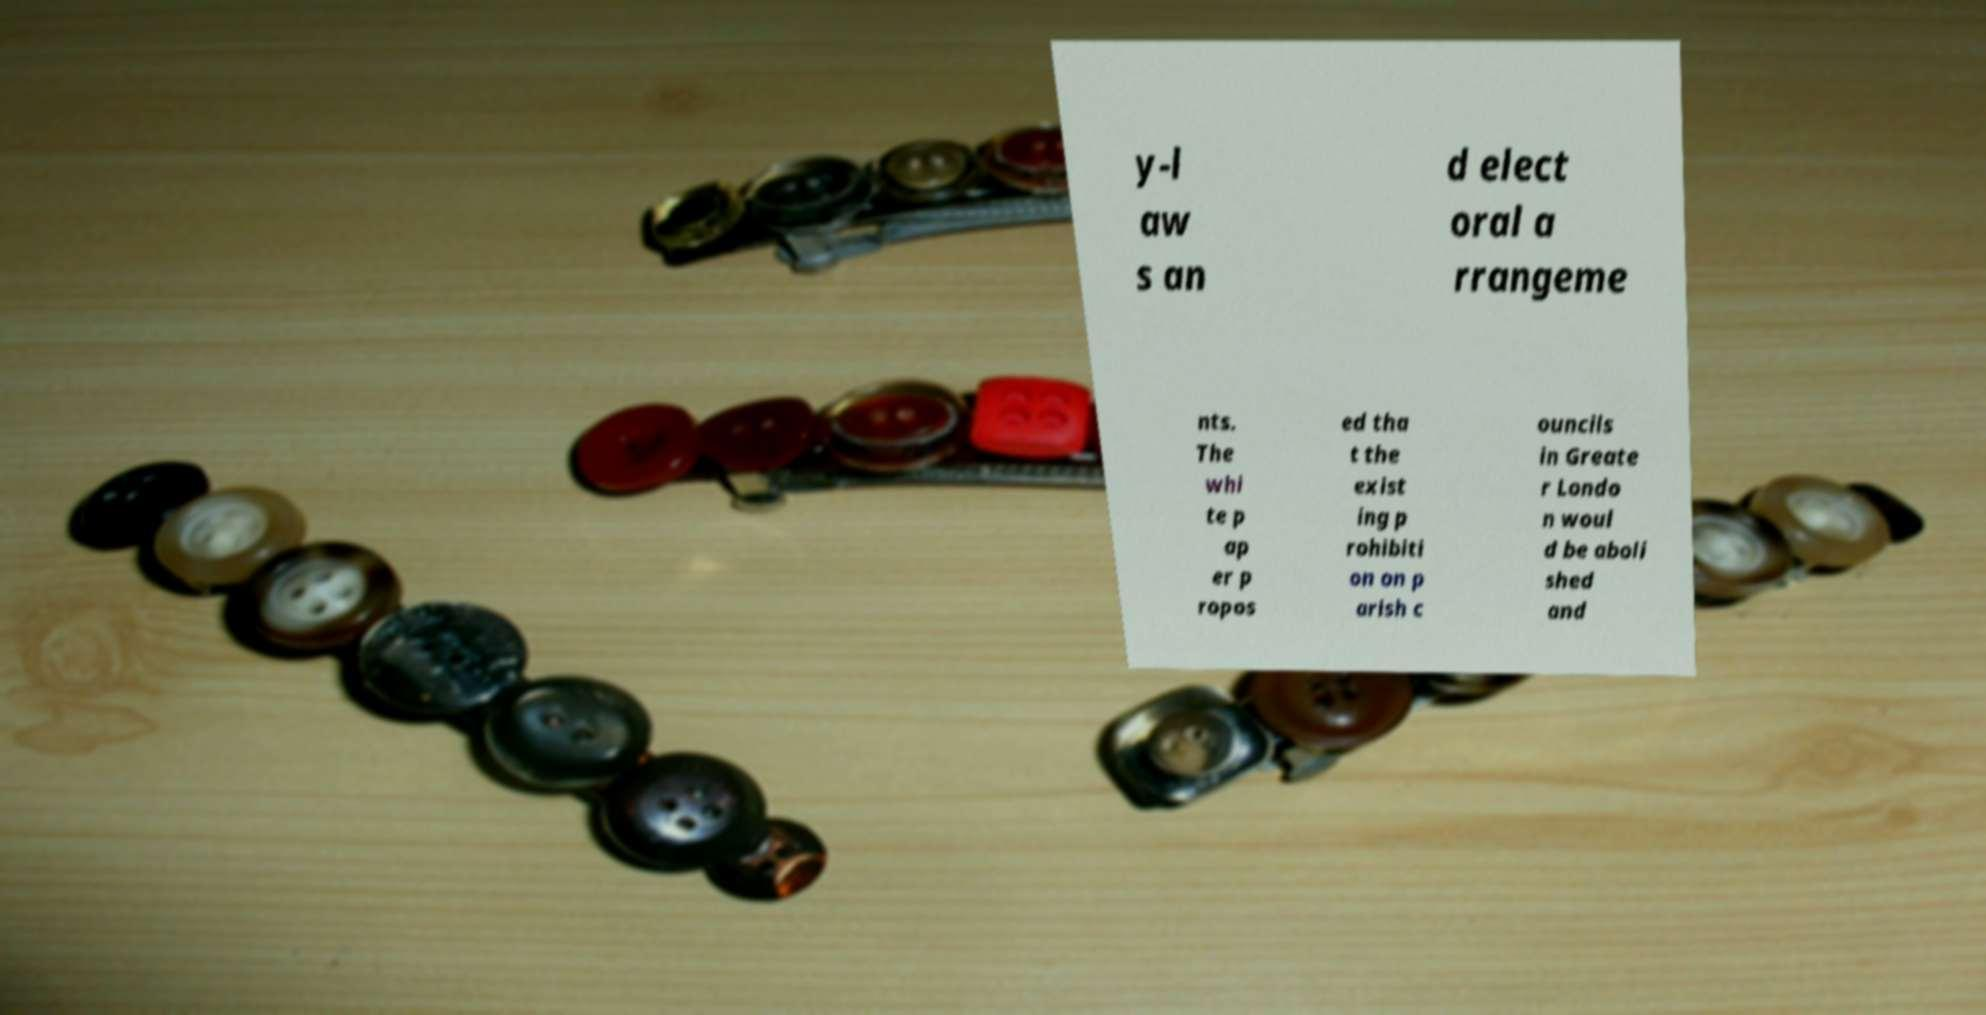Please identify and transcribe the text found in this image. y-l aw s an d elect oral a rrangeme nts. The whi te p ap er p ropos ed tha t the exist ing p rohibiti on on p arish c ouncils in Greate r Londo n woul d be aboli shed and 